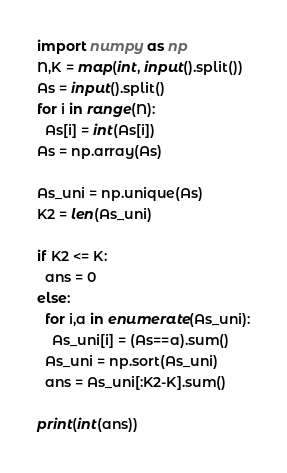<code> <loc_0><loc_0><loc_500><loc_500><_Python_>import numpy as np
N,K = map(int, input().split())
As = input().split()
for i in range(N):
  As[i] = int(As[i])
As = np.array(As)

As_uni = np.unique(As)
K2 = len(As_uni)

if K2 <= K:
  ans = 0
else:
  for i,a in enumerate(As_uni):
    As_uni[i] = (As==a).sum()
  As_uni = np.sort(As_uni)
  ans = As_uni[:K2-K].sum()
  
print(int(ans))</code> 